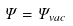<formula> <loc_0><loc_0><loc_500><loc_500>\Psi = \Psi _ { v a c }</formula> 